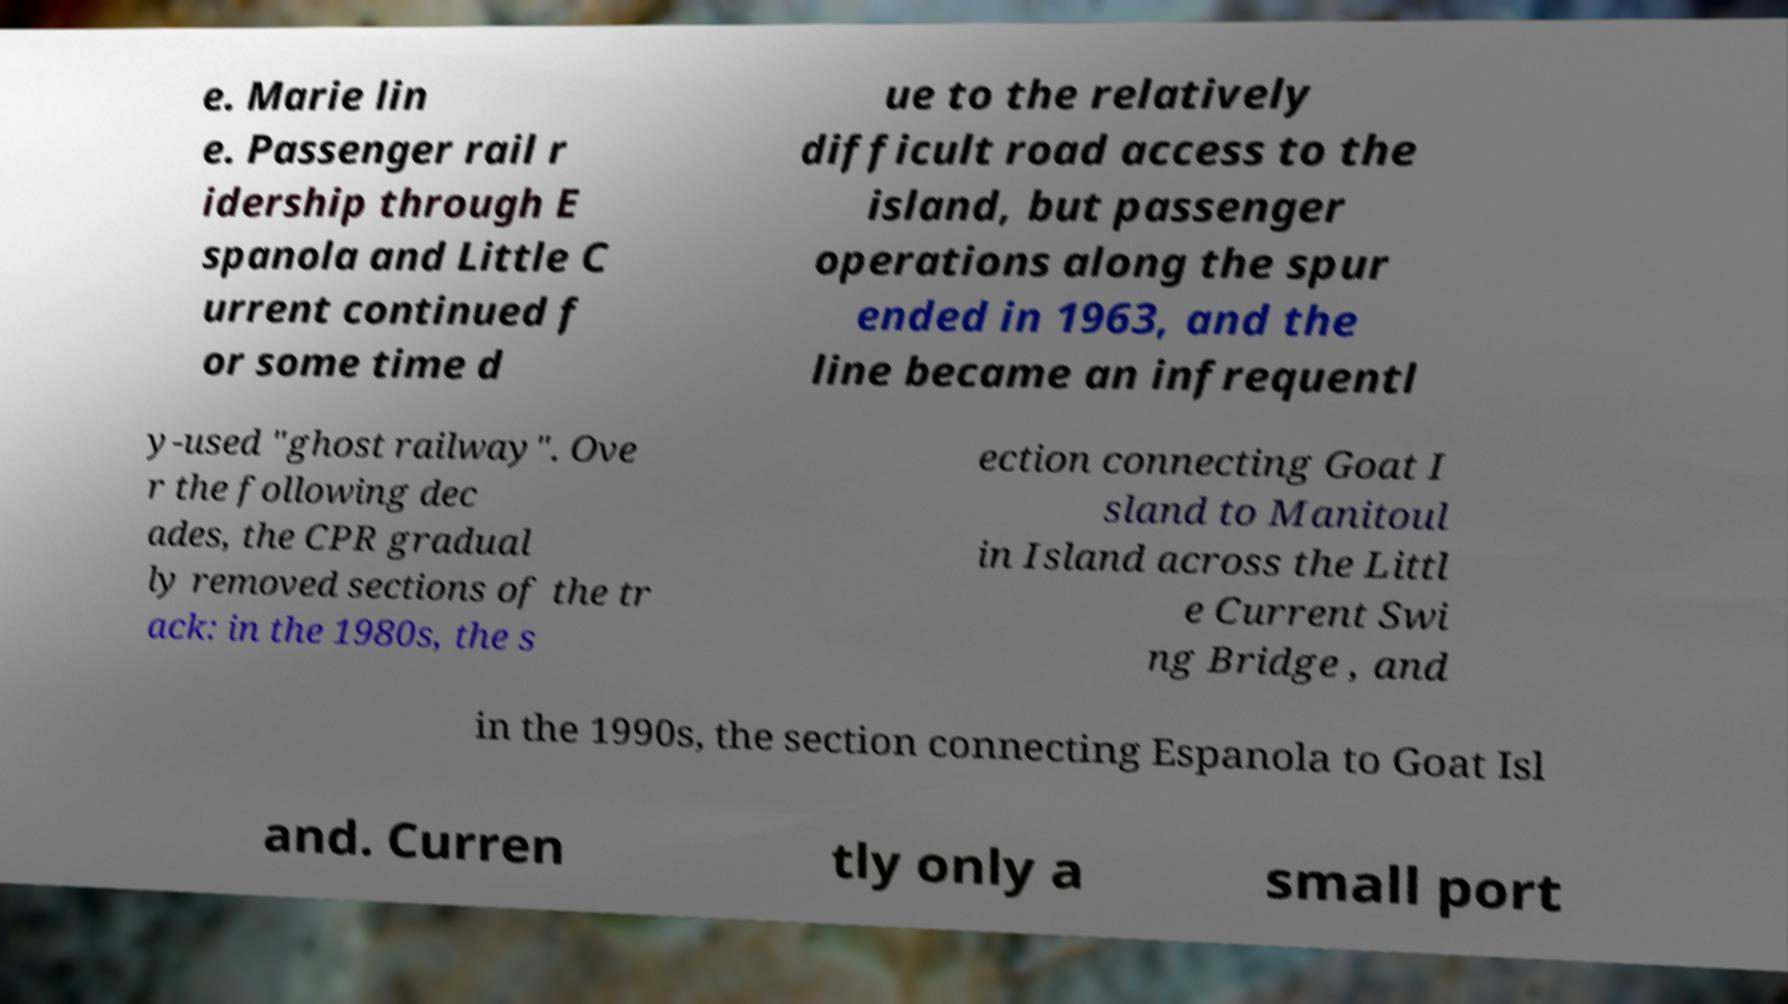There's text embedded in this image that I need extracted. Can you transcribe it verbatim? e. Marie lin e. Passenger rail r idership through E spanola and Little C urrent continued f or some time d ue to the relatively difficult road access to the island, but passenger operations along the spur ended in 1963, and the line became an infrequentl y-used "ghost railway". Ove r the following dec ades, the CPR gradual ly removed sections of the tr ack: in the 1980s, the s ection connecting Goat I sland to Manitoul in Island across the Littl e Current Swi ng Bridge , and in the 1990s, the section connecting Espanola to Goat Isl and. Curren tly only a small port 